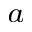<formula> <loc_0><loc_0><loc_500><loc_500>^ { a }</formula> 